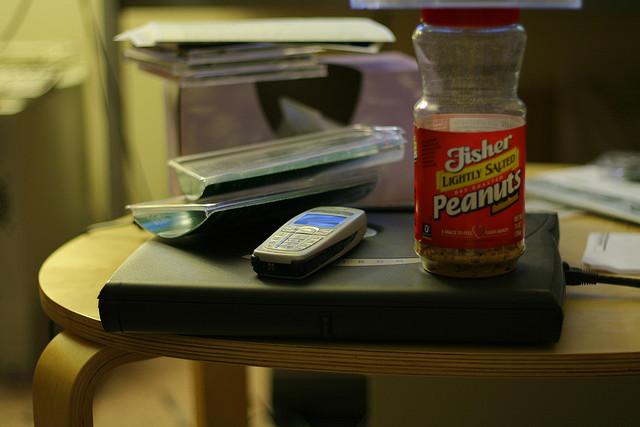What type of nuts are in the jar?
Concise answer only. Peanuts. What is beside the jar of Fisher peanuts?
Concise answer only. Cell phone. Is there something on top of the jar?
Answer briefly. Yes. 